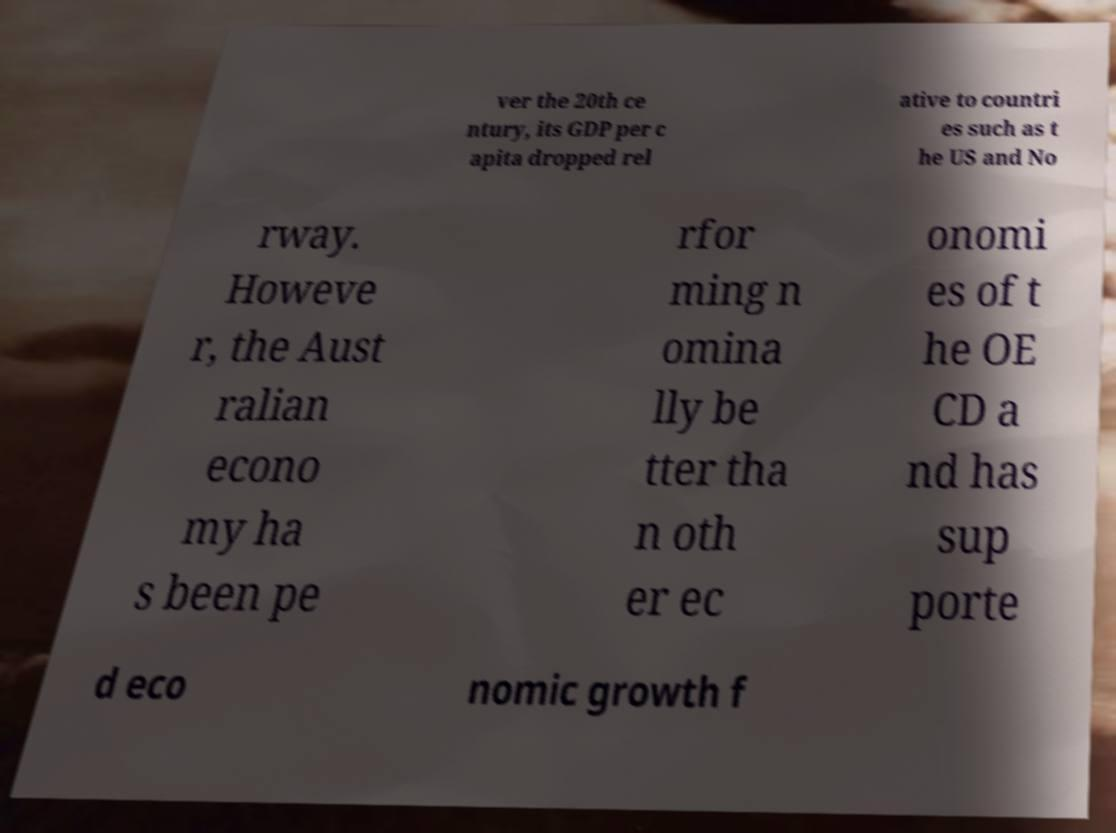Please read and relay the text visible in this image. What does it say? ver the 20th ce ntury, its GDP per c apita dropped rel ative to countri es such as t he US and No rway. Howeve r, the Aust ralian econo my ha s been pe rfor ming n omina lly be tter tha n oth er ec onomi es of t he OE CD a nd has sup porte d eco nomic growth f 